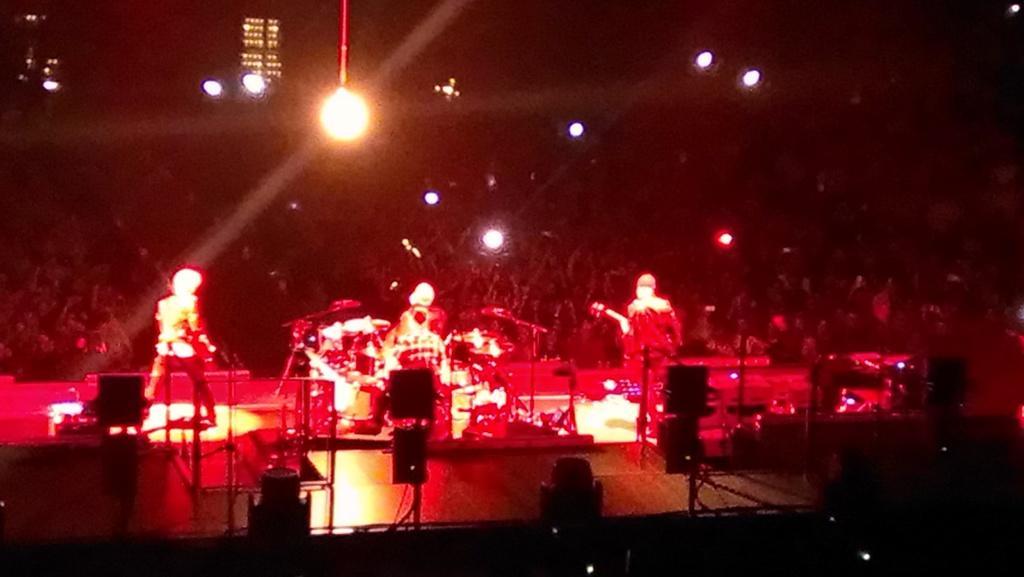How would you summarize this image in a sentence or two? In this picture there is a man who is playing drums. Beside him there are two persons were playing on guitar. In front of them we can see the mics. At the bottom we can see the focus lights and speakers. In the background we can see the audience. At the top we can see many lights. 